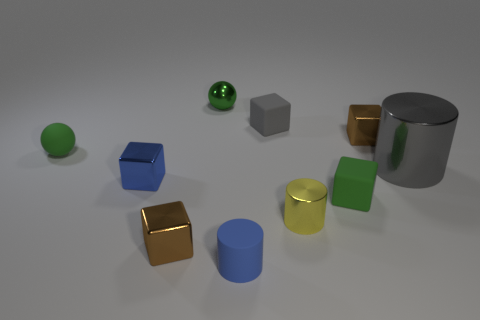Subtract all small blue blocks. How many blocks are left? 4 Subtract all green spheres. How many brown cubes are left? 2 Subtract 3 cubes. How many cubes are left? 2 Subtract all blue blocks. How many blocks are left? 4 Subtract all spheres. How many objects are left? 8 Subtract all blue blocks. Subtract all red balls. How many blocks are left? 4 Subtract 1 green cubes. How many objects are left? 9 Subtract all small blue metallic things. Subtract all gray cylinders. How many objects are left? 8 Add 2 brown metal blocks. How many brown metal blocks are left? 4 Add 4 big matte cylinders. How many big matte cylinders exist? 4 